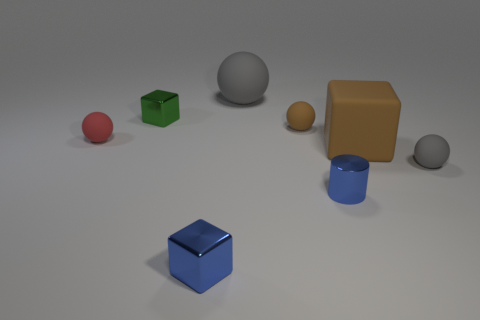Subtract all large gray balls. How many balls are left? 3 Add 1 tiny blue metal cylinders. How many objects exist? 9 Subtract all gray spheres. How many spheres are left? 2 Subtract all cubes. How many objects are left? 5 Subtract all gray blocks. How many gray cylinders are left? 0 Subtract 2 balls. How many balls are left? 2 Subtract all purple cylinders. Subtract all brown blocks. How many cylinders are left? 1 Subtract all big yellow matte balls. Subtract all green metallic objects. How many objects are left? 7 Add 8 small brown balls. How many small brown balls are left? 9 Add 4 brown metal cubes. How many brown metal cubes exist? 4 